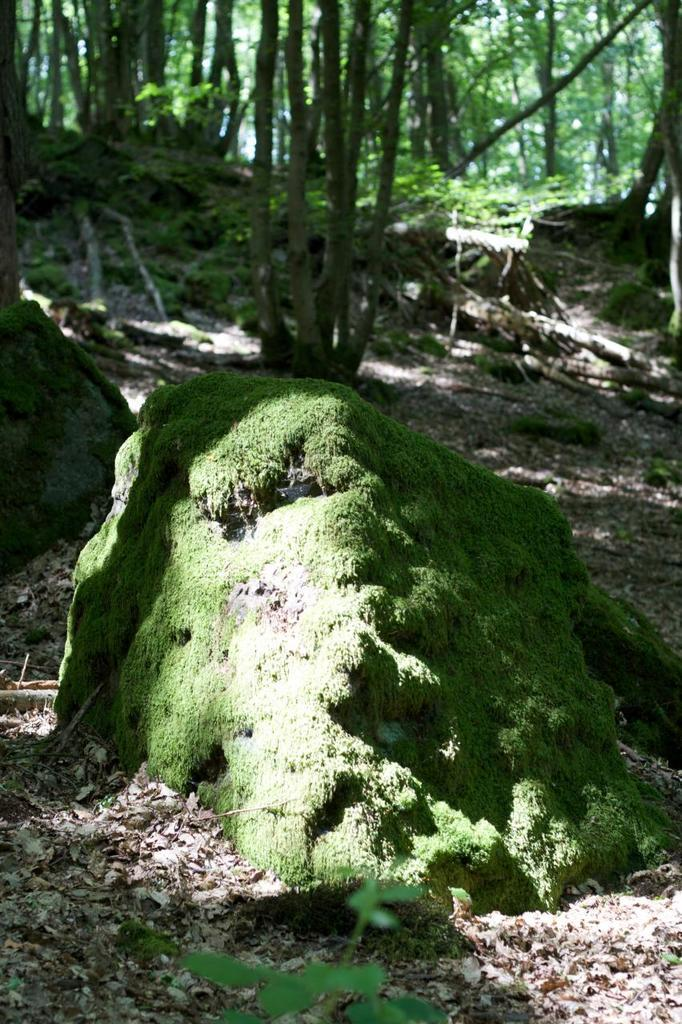What type of surface can be seen in the image? Ground is visible in the image. What is covering the ground in the image? Dried leaves are present on the ground. What type of vegetation is in the image? There are plants and trees present in the image. What other objects can be seen on the ground in the image? Stones are visible in the image. What type of wound can be seen on the tree in the image? There is no wound visible on any tree in the image. What type of harmony is being created by the plants and trees in the image? The image does not depict any concept of harmony between the plants and trees; it simply shows their presence in the environment. 